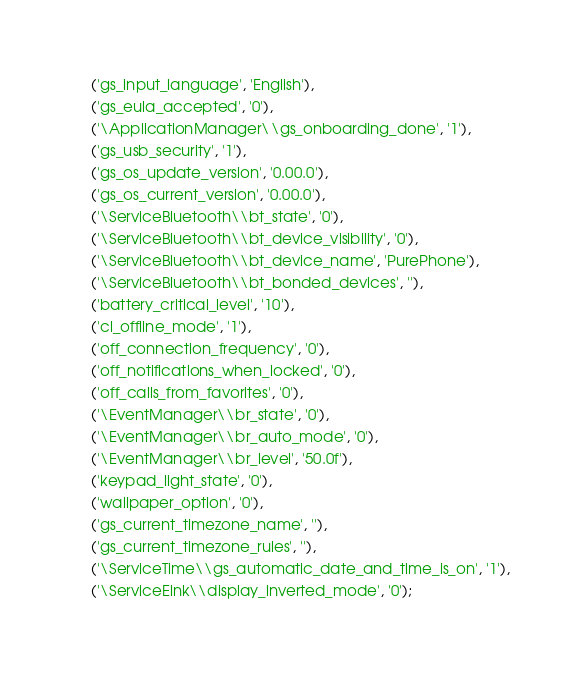Convert code to text. <code><loc_0><loc_0><loc_500><loc_500><_SQL_>    ('gs_input_language', 'English'),
    ('gs_eula_accepted', '0'),
    ('\ApplicationManager\\gs_onboarding_done', '1'),
    ('gs_usb_security', '1'),
    ('gs_os_update_version', '0.00.0'),
    ('gs_os_current_version', '0.00.0'),
    ('\ServiceBluetooth\\bt_state', '0'),
    ('\ServiceBluetooth\\bt_device_visibility', '0'),
    ('\ServiceBluetooth\\bt_device_name', 'PurePhone'),
    ('\ServiceBluetooth\\bt_bonded_devices', ''),
    ('battery_critical_level', '10'),
    ('cl_offline_mode', '1'),
    ('off_connection_frequency', '0'),
    ('off_notifications_when_locked', '0'),
    ('off_calls_from_favorites', '0'),
    ('\EventManager\\br_state', '0'),
    ('\EventManager\\br_auto_mode', '0'),
    ('\EventManager\\br_level', '50.0f'),
    ('keypad_light_state', '0'),
    ('wallpaper_option', '0'),
    ('gs_current_timezone_name', ''),
    ('gs_current_timezone_rules', ''),
    ('\ServiceTime\\gs_automatic_date_and_time_is_on', '1'),
    ('\ServiceEink\\display_inverted_mode', '0');


</code> 